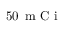Convert formula to latex. <formula><loc_0><loc_0><loc_500><loc_500>5 0 \, m C i</formula> 